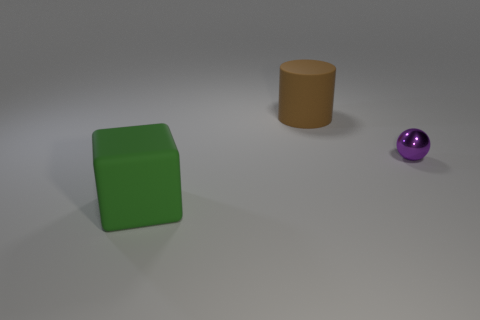Are there any other things that have the same material as the purple sphere?
Offer a very short reply. No. Is there any other thing that is the same size as the purple shiny ball?
Offer a very short reply. No. There is a rubber object that is behind the green rubber cube; does it have the same color as the small metal thing behind the large green object?
Provide a short and direct response. No. There is a matte thing in front of the large rubber thing that is behind the large matte thing that is left of the cylinder; what is its size?
Give a very brief answer. Large. There is a thing that is both in front of the big brown cylinder and right of the green matte block; what is its shape?
Offer a very short reply. Sphere. Are there an equal number of green blocks to the right of the green block and brown cylinders on the left side of the cylinder?
Offer a very short reply. Yes. Is there a yellow object that has the same material as the purple sphere?
Make the answer very short. No. Does the big object on the left side of the rubber cylinder have the same material as the purple thing?
Offer a very short reply. No. How big is the object that is right of the green rubber object and on the left side of the purple shiny sphere?
Your response must be concise. Large. What is the color of the metallic sphere?
Keep it short and to the point. Purple. 